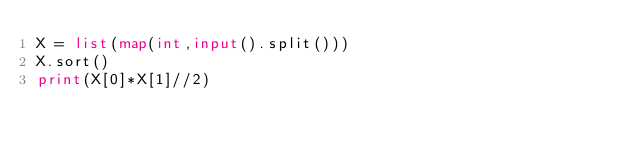<code> <loc_0><loc_0><loc_500><loc_500><_Python_>X = list(map(int,input().split()))
X.sort()
print(X[0]*X[1]//2)
</code> 